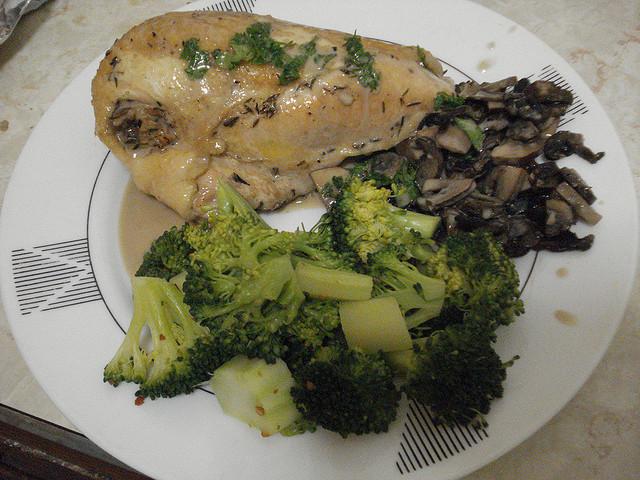Which design is shown in on the plate?
Answer briefly. Triangle. What kind of meat is this??
Short answer required. Chicken. How many types are food are on the plate?
Concise answer only. 3. Is this fruit and vegetables?
Concise answer only. No. Is the broccoli cooked?
Concise answer only. Yes. What color is the plate?
Quick response, please. White. What is the vegetable on the bottom of the plate?
Quick response, please. Broccoli. 